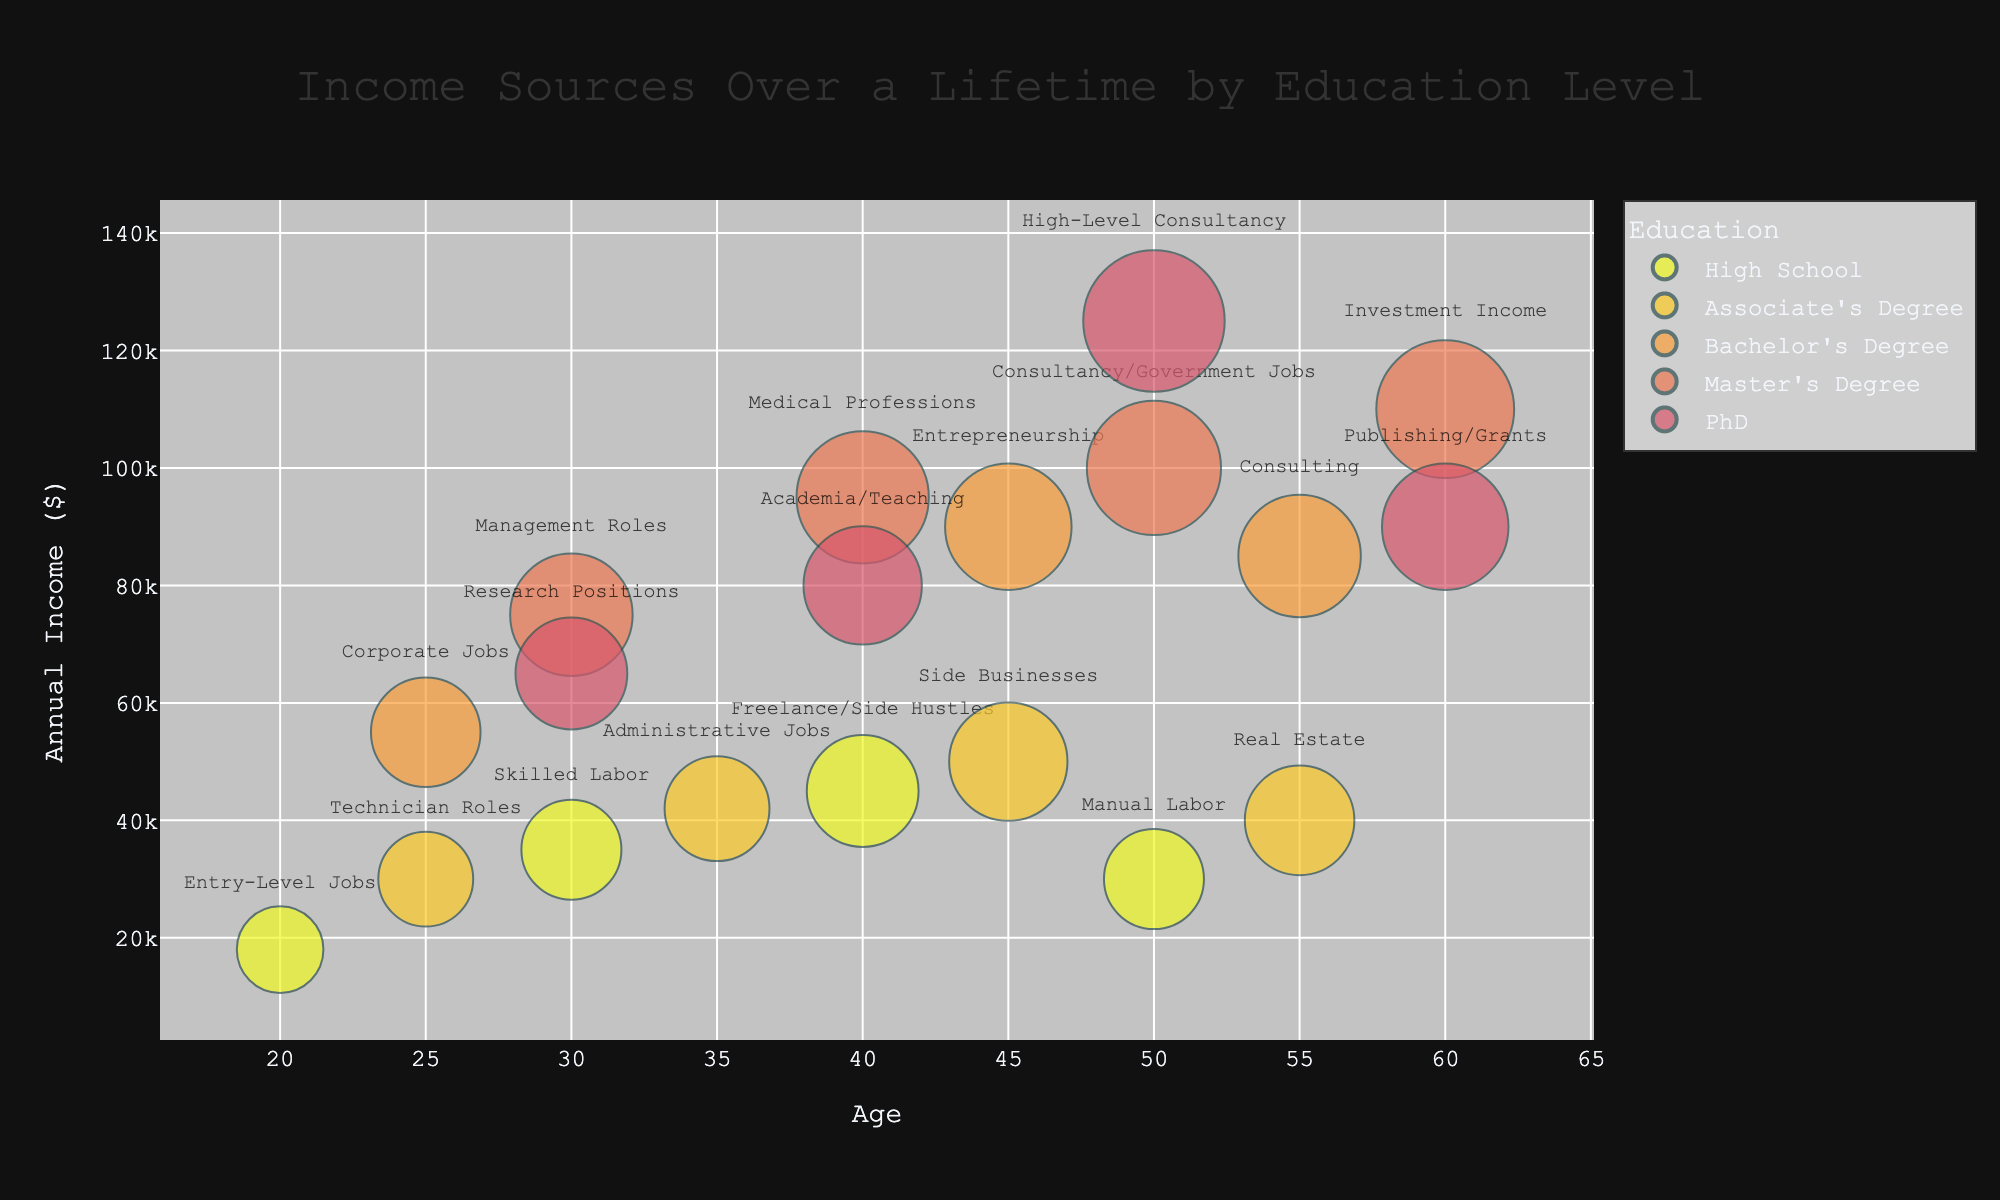What's the title of the chart? The title is located at the top of the chart, and it's set to be easily readable.
Answer: Income Sources Over a Lifetime by Education Level How many different education levels are represented in the chart? By analyzing the legend and the various colors in the chart, we can count the distinct education levels.
Answer: 4 What's the highest annual income shown in the chart? Look for the bubble placed at the highest position on the y-axis, then check the income value displayed.
Answer: $125,000 Which income source corresponds to the largest bubble? By observing the sizes of the bubbles and identifying the one with the largest diameter, we can see the corresponding income source from the hover labels or directly on the bubble.
Answer: High-Level Consultancy At what age does a person with a Bachelor's Degree have the highest annual income? Locate all bubbles associated with a Bachelor's Degree and find the one positioned highest along the y-axis, then read the corresponding age on the x-axis.
Answer: 45 What's the total number of income sources for people with a Master's Degree? Count all bubbles color-coded for a Master's Degree by tracing the legend and the respective bubbles.
Answer: 4 Which education level has the most diverse range of income sources? Compare the counts of different income sources (bubbles) for each education level.
Answer: High School How does the annual income of a 40-year-old with a High School diploma compare to a 40-year-old with a Bachelor's Degree? Identify and compare the bubbles representing 40-year-olds for both education levels and read their y-axis values.
Answer: $45,000 (High School) vs. $95,000 (Master's Degree) What's the average annual income for individuals with a PhD at the age of 40 and 50? Find the annual income for PhD holders at ages 40 and 50, then calculate the average: ($80,000 + $125,000) / 2.
Answer: $102,500 Among the income sources for individuals aged 60, which has the lowest annual income? Filter the bubbles representing individuals aged 60 and compare their y-axis values to find the lowest one.
Answer: Publishing/Grants 